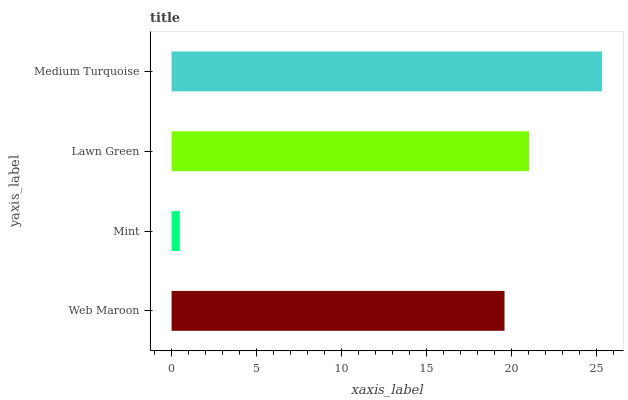Is Mint the minimum?
Answer yes or no. Yes. Is Medium Turquoise the maximum?
Answer yes or no. Yes. Is Lawn Green the minimum?
Answer yes or no. No. Is Lawn Green the maximum?
Answer yes or no. No. Is Lawn Green greater than Mint?
Answer yes or no. Yes. Is Mint less than Lawn Green?
Answer yes or no. Yes. Is Mint greater than Lawn Green?
Answer yes or no. No. Is Lawn Green less than Mint?
Answer yes or no. No. Is Lawn Green the high median?
Answer yes or no. Yes. Is Web Maroon the low median?
Answer yes or no. Yes. Is Mint the high median?
Answer yes or no. No. Is Medium Turquoise the low median?
Answer yes or no. No. 